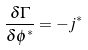<formula> <loc_0><loc_0><loc_500><loc_500>\frac { \delta \Gamma } { \delta \phi ^ { * } } = - j ^ { * }</formula> 